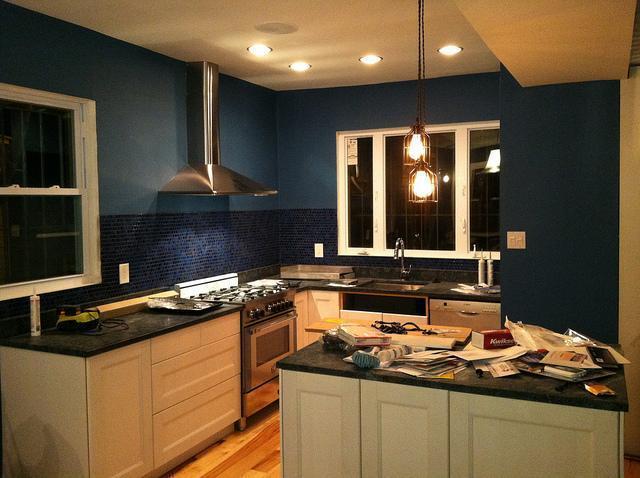How many trucks are there?
Give a very brief answer. 0. 